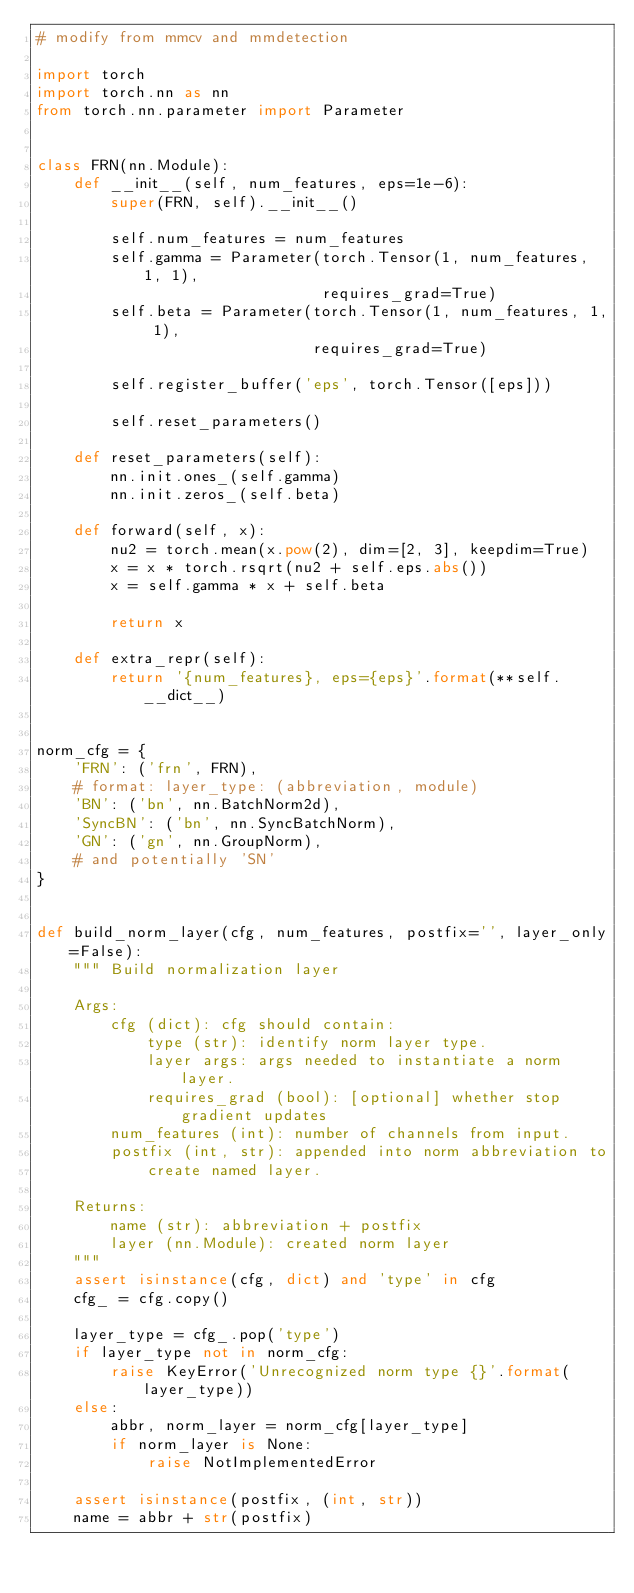<code> <loc_0><loc_0><loc_500><loc_500><_Python_># modify from mmcv and mmdetection

import torch
import torch.nn as nn
from torch.nn.parameter import Parameter


class FRN(nn.Module):
    def __init__(self, num_features, eps=1e-6):
        super(FRN, self).__init__()

        self.num_features = num_features
        self.gamma = Parameter(torch.Tensor(1, num_features, 1, 1),
                               requires_grad=True)
        self.beta = Parameter(torch.Tensor(1, num_features, 1, 1),
                              requires_grad=True)

        self.register_buffer('eps', torch.Tensor([eps]))

        self.reset_parameters()

    def reset_parameters(self):
        nn.init.ones_(self.gamma)
        nn.init.zeros_(self.beta)

    def forward(self, x):
        nu2 = torch.mean(x.pow(2), dim=[2, 3], keepdim=True)
        x = x * torch.rsqrt(nu2 + self.eps.abs())
        x = self.gamma * x + self.beta

        return x

    def extra_repr(self):
        return '{num_features}, eps={eps}'.format(**self.__dict__)


norm_cfg = {
    'FRN': ('frn', FRN),
    # format: layer_type: (abbreviation, module)
    'BN': ('bn', nn.BatchNorm2d),
    'SyncBN': ('bn', nn.SyncBatchNorm),
    'GN': ('gn', nn.GroupNorm),
    # and potentially 'SN'
}


def build_norm_layer(cfg, num_features, postfix='', layer_only=False):
    """ Build normalization layer

    Args:
        cfg (dict): cfg should contain:
            type (str): identify norm layer type.
            layer args: args needed to instantiate a norm layer.
            requires_grad (bool): [optional] whether stop gradient updates
        num_features (int): number of channels from input.
        postfix (int, str): appended into norm abbreviation to
            create named layer.

    Returns:
        name (str): abbreviation + postfix
        layer (nn.Module): created norm layer
    """
    assert isinstance(cfg, dict) and 'type' in cfg
    cfg_ = cfg.copy()

    layer_type = cfg_.pop('type')
    if layer_type not in norm_cfg:
        raise KeyError('Unrecognized norm type {}'.format(layer_type))
    else:
        abbr, norm_layer = norm_cfg[layer_type]
        if norm_layer is None:
            raise NotImplementedError

    assert isinstance(postfix, (int, str))
    name = abbr + str(postfix)
</code> 